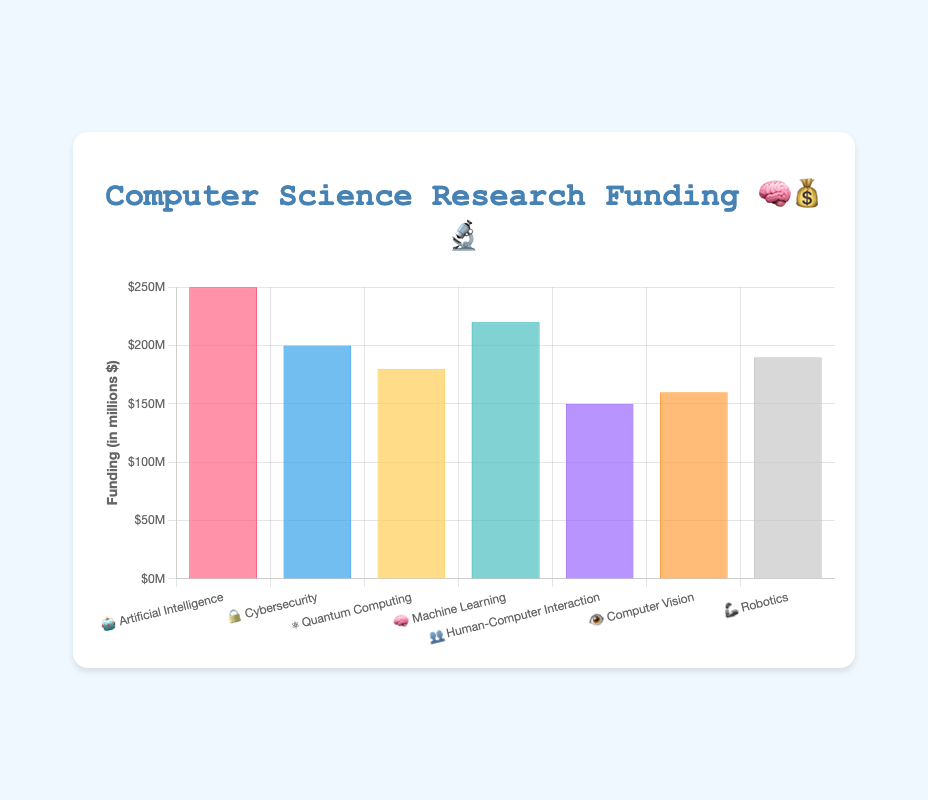What is the total amount of funding for Artificial Intelligence? The funding for Artificial Intelligence can be directly read from the chart under the category labeled "🤖 Artificial Intelligence", which is $250 million.
Answer: $250M Which research area received the least amount of funding? The research area with the least funding can be identified by looking for the shortest bar in the chart. "👥 Human-Computer Interaction" has the least funding of $150 million.
Answer: Human-Computer Interaction How much more funding does Artificial Intelligence receive compared to Quantum Computing? According to the chart, Artificial Intelligence receives $250 million, and Quantum Computing receives $180 million. The difference is calculated as $250M - $180M = $70M.
Answer: $70M What is the average funding amount across all research areas? There are 7 research areas with funding of $250M, $200M, $180M, $220M, $150M, $160M, $190M respectively. The sum is $250 + $200 + $180 + $220 + $150 + $160 + $190 = $1350M. The average is $1350M / 7 = $192.86M.
Answer: $192.86M Which research area received the second-highest funding? The funding amounts in descending order are $250M (Artificial Intelligence), $220M (Machine Learning), and so on. The second highest is therefore "🧠 Machine Learning" with $220 million.
Answer: Machine Learning What is the combined funding for Cybersecurity and Robotics? The funding for Cybersecurity is $200M, and for Robotics, it is $190M. The combined funding is $200M + $190M = $390M.
Answer: $390M Is the funding for Human-Computer Interaction higher or lower than that for Computer Vision? The funding for Human-Computer Interaction is $150M, and for Computer Vision, it is $160M. Therefore, Human-Computer Interaction funding is lower.
Answer: Lower By how much does Robotics funding exceed Quantum Computing funding? According to the chart, the funding for Robotics is $190M, while Quantum Computing has $180M. The difference is $190M - $180M = $10M.
Answer: $10M What percentage of the total funding is allocated to Artificial Intelligence? The total funding across all areas is $1350 million. Artificial Intelligence received $250 million. The percentage is calculated as ($250M / $1350M) * 100 = 18.52%.
Answer: 18.52% What are the two research areas with the closest funding amounts? By examining the chart for adjacent funding amounts, we see that Quantum Computing and Robotics have the closest funding of $180M and $190M respectively. The difference is 10M.
Answer: Quantum Computing and Robotics 